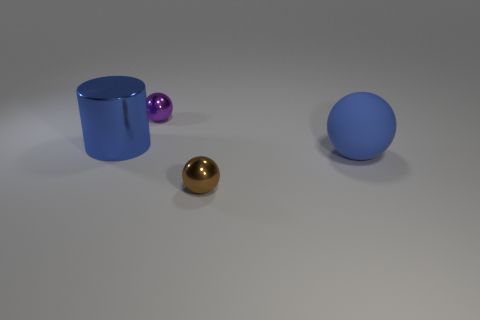How big is the metallic ball in front of the small purple shiny sphere?
Your answer should be very brief. Small. The blue rubber object is what size?
Your answer should be compact. Large. There is a sphere to the right of the metal object that is on the right side of the small object on the left side of the small brown metallic ball; what is its size?
Your answer should be very brief. Large. Are there any small purple objects made of the same material as the cylinder?
Keep it short and to the point. Yes. There is a big rubber object; what shape is it?
Offer a very short reply. Sphere. The small object that is made of the same material as the purple ball is what color?
Keep it short and to the point. Brown. What number of blue objects are matte things or cylinders?
Your answer should be very brief. 2. Is the number of large purple metallic cylinders greater than the number of metallic things?
Provide a succinct answer. No. How many objects are either tiny metallic things behind the large blue metallic cylinder or metallic things in front of the purple thing?
Your answer should be compact. 3. There is a thing that is the same size as the blue shiny cylinder; what color is it?
Your answer should be compact. Blue. 